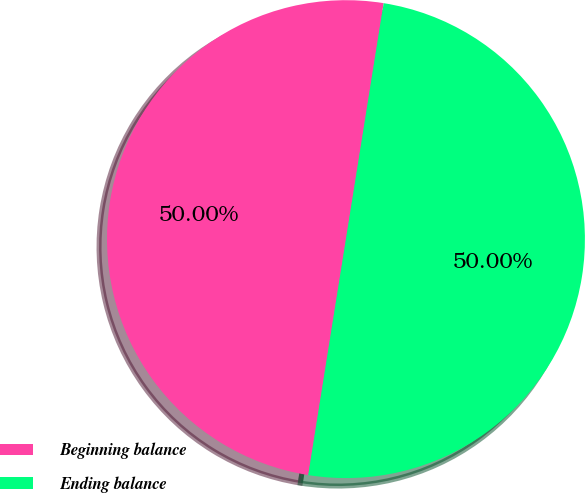Convert chart to OTSL. <chart><loc_0><loc_0><loc_500><loc_500><pie_chart><fcel>Beginning balance<fcel>Ending balance<nl><fcel>50.0%<fcel>50.0%<nl></chart> 